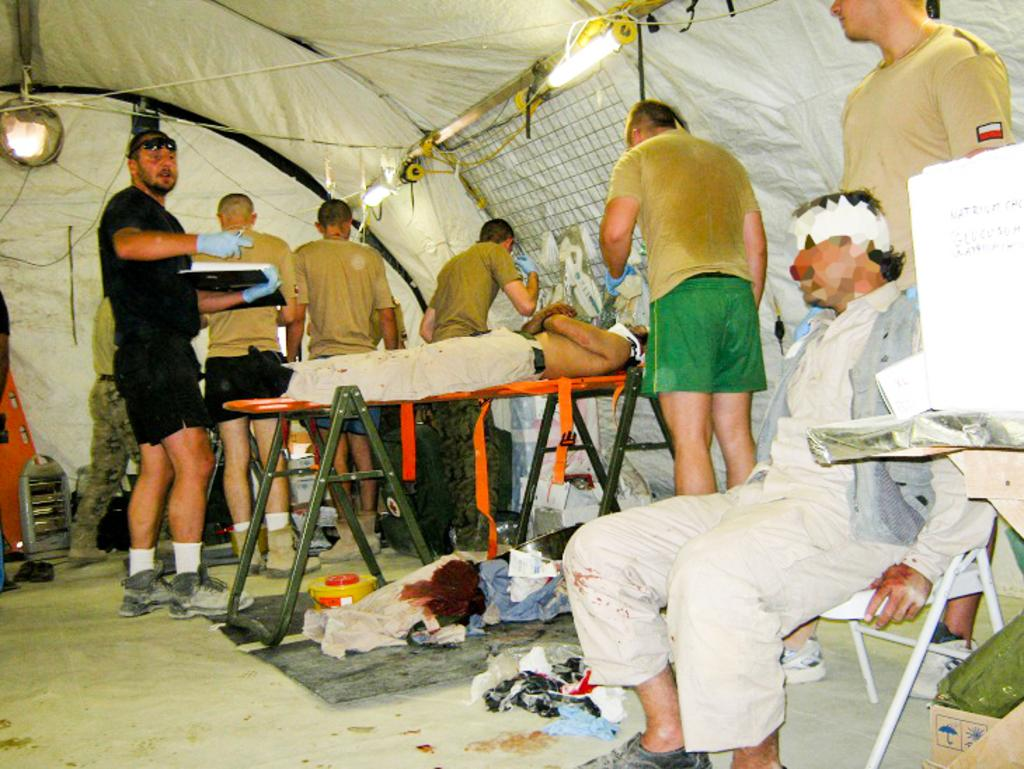What are the people in the image doing? The people in the image are sitting, standing, and lying. What objects can be seen in the image besides people? There are clothes and boxes visible in the image. What is in the background of the image? There is a tent and lights in the background of the image. What type of advertisement can be seen on the tent in the image? There is no advertisement visible on the tent in the image. How many rabbits are hopping around in the image? There are no rabbits present in the image. 